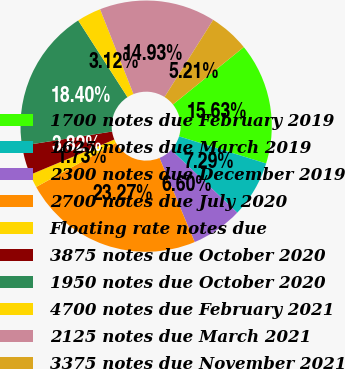Convert chart. <chart><loc_0><loc_0><loc_500><loc_500><pie_chart><fcel>1700 notes due February 2019<fcel>1625 notes due March 2019<fcel>2300 notes due December 2019<fcel>2700 notes due July 2020<fcel>Floating rate notes due<fcel>3875 notes due October 2020<fcel>1950 notes due October 2020<fcel>4700 notes due February 2021<fcel>2125 notes due March 2021<fcel>3375 notes due November 2021<nl><fcel>15.63%<fcel>7.29%<fcel>6.6%<fcel>23.27%<fcel>1.73%<fcel>3.82%<fcel>18.4%<fcel>3.12%<fcel>14.93%<fcel>5.21%<nl></chart> 